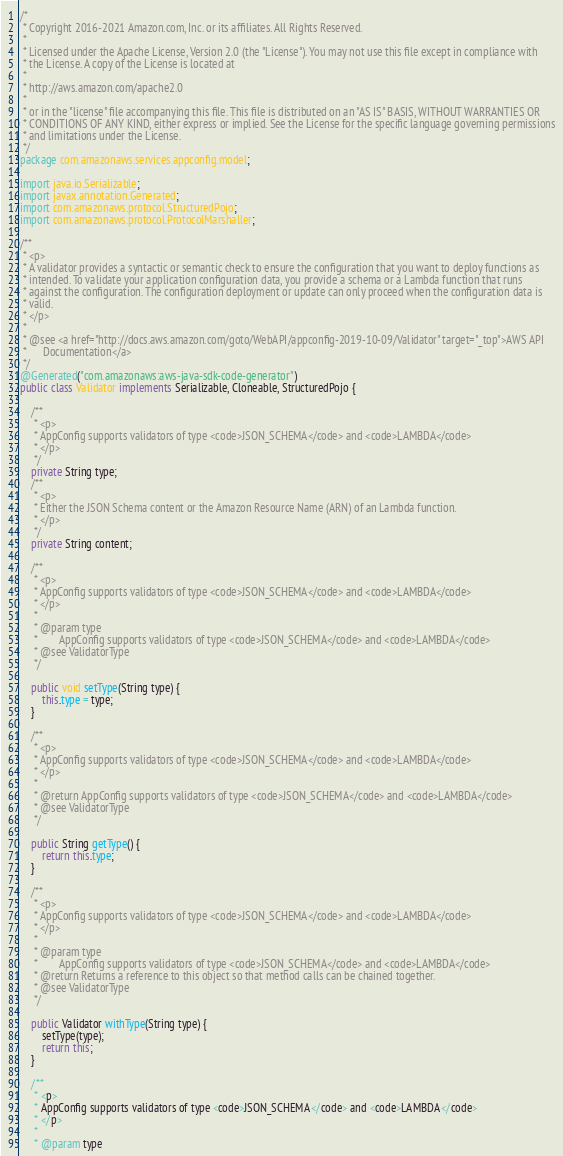<code> <loc_0><loc_0><loc_500><loc_500><_Java_>/*
 * Copyright 2016-2021 Amazon.com, Inc. or its affiliates. All Rights Reserved.
 * 
 * Licensed under the Apache License, Version 2.0 (the "License"). You may not use this file except in compliance with
 * the License. A copy of the License is located at
 * 
 * http://aws.amazon.com/apache2.0
 * 
 * or in the "license" file accompanying this file. This file is distributed on an "AS IS" BASIS, WITHOUT WARRANTIES OR
 * CONDITIONS OF ANY KIND, either express or implied. See the License for the specific language governing permissions
 * and limitations under the License.
 */
package com.amazonaws.services.appconfig.model;

import java.io.Serializable;
import javax.annotation.Generated;
import com.amazonaws.protocol.StructuredPojo;
import com.amazonaws.protocol.ProtocolMarshaller;

/**
 * <p>
 * A validator provides a syntactic or semantic check to ensure the configuration that you want to deploy functions as
 * intended. To validate your application configuration data, you provide a schema or a Lambda function that runs
 * against the configuration. The configuration deployment or update can only proceed when the configuration data is
 * valid.
 * </p>
 * 
 * @see <a href="http://docs.aws.amazon.com/goto/WebAPI/appconfig-2019-10-09/Validator" target="_top">AWS API
 *      Documentation</a>
 */
@Generated("com.amazonaws:aws-java-sdk-code-generator")
public class Validator implements Serializable, Cloneable, StructuredPojo {

    /**
     * <p>
     * AppConfig supports validators of type <code>JSON_SCHEMA</code> and <code>LAMBDA</code>
     * </p>
     */
    private String type;
    /**
     * <p>
     * Either the JSON Schema content or the Amazon Resource Name (ARN) of an Lambda function.
     * </p>
     */
    private String content;

    /**
     * <p>
     * AppConfig supports validators of type <code>JSON_SCHEMA</code> and <code>LAMBDA</code>
     * </p>
     * 
     * @param type
     *        AppConfig supports validators of type <code>JSON_SCHEMA</code> and <code>LAMBDA</code>
     * @see ValidatorType
     */

    public void setType(String type) {
        this.type = type;
    }

    /**
     * <p>
     * AppConfig supports validators of type <code>JSON_SCHEMA</code> and <code>LAMBDA</code>
     * </p>
     * 
     * @return AppConfig supports validators of type <code>JSON_SCHEMA</code> and <code>LAMBDA</code>
     * @see ValidatorType
     */

    public String getType() {
        return this.type;
    }

    /**
     * <p>
     * AppConfig supports validators of type <code>JSON_SCHEMA</code> and <code>LAMBDA</code>
     * </p>
     * 
     * @param type
     *        AppConfig supports validators of type <code>JSON_SCHEMA</code> and <code>LAMBDA</code>
     * @return Returns a reference to this object so that method calls can be chained together.
     * @see ValidatorType
     */

    public Validator withType(String type) {
        setType(type);
        return this;
    }

    /**
     * <p>
     * AppConfig supports validators of type <code>JSON_SCHEMA</code> and <code>LAMBDA</code>
     * </p>
     * 
     * @param type</code> 